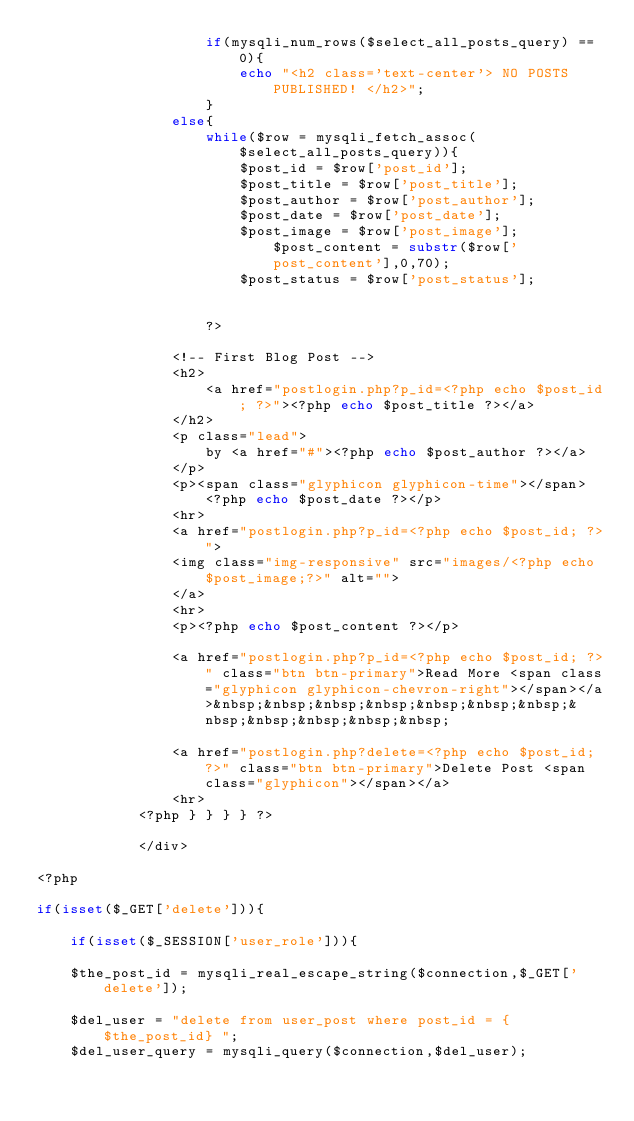Convert code to text. <code><loc_0><loc_0><loc_500><loc_500><_PHP_>                    if(mysqli_num_rows($select_all_posts_query) == 0){
                        echo "<h2 class='text-center'> NO POSTS PUBLISHED! </h2>";
                    }
                else{
                    while($row = mysqli_fetch_assoc($select_all_posts_query)){
                        $post_id = $row['post_id'];
                        $post_title = $row['post_title'];
                        $post_author = $row['post_author'];
                        $post_date = $row['post_date'];
                        $post_image = $row['post_image'];     $post_content = substr($row['post_content'],0,70);
                        $post_status = $row['post_status'];
                    
                            
                    ?>    

                <!-- First Blog Post -->
                <h2>
                    <a href="postlogin.php?p_id=<?php echo $post_id; ?>"><?php echo $post_title ?></a>
                </h2>
                <p class="lead">
                    by <a href="#"><?php echo $post_author ?></a>
                </p>
                <p><span class="glyphicon glyphicon-time"></span> <?php echo $post_date ?></p>
                <hr>
                <a href="postlogin.php?p_id=<?php echo $post_id; ?>">
                <img class="img-responsive" src="images/<?php echo $post_image;?>" alt="">   
                </a>    
                <hr>
                <p><?php echo $post_content ?></p>
                
                <a href="postlogin.php?p_id=<?php echo $post_id; ?>" class="btn btn-primary">Read More <span class="glyphicon glyphicon-chevron-right"></span></a>&nbsp;&nbsp;&nbsp;&nbsp;&nbsp;&nbsp;&nbsp;&nbsp;&nbsp;&nbsp;&nbsp;&nbsp;
                
                <a href="postlogin.php?delete=<?php echo $post_id; ?>" class="btn btn-primary">Delete Post <span class="glyphicon"></span></a>
                <hr>
            <?php } } } } ?>

            </div>
            
<?php               
               
if(isset($_GET['delete'])){
 
    if(isset($_SESSION['user_role'])){
    
    $the_post_id = mysqli_real_escape_string($connection,$_GET['delete']);
    
    $del_user = "delete from user_post where post_id = {$the_post_id} ";
    $del_user_query = mysqli_query($connection,$del_user);       
</code> 